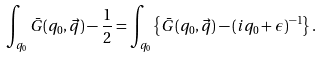Convert formula to latex. <formula><loc_0><loc_0><loc_500><loc_500>\int _ { q _ { 0 } } \bar { G } ( q _ { 0 } , \vec { q } ) - \frac { 1 } { 2 } = \int _ { q _ { 0 } } \left \{ \bar { G } ( q _ { 0 } , \vec { q } ) - ( i q _ { 0 } + \epsilon ) ^ { - 1 } \right \} .</formula> 